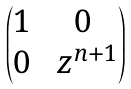Convert formula to latex. <formula><loc_0><loc_0><loc_500><loc_500>\begin{pmatrix} 1 & 0 \\ 0 & \ z ^ { n + 1 } \end{pmatrix}</formula> 